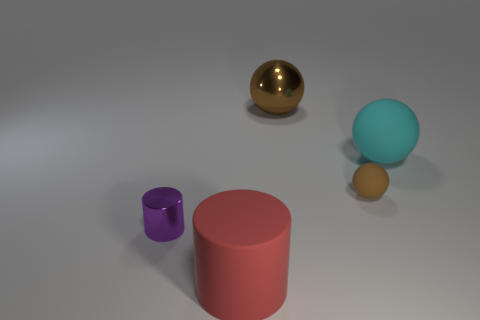What is the color of the big shiny thing?
Offer a terse response. Brown. Is the color of the cylinder behind the big red cylinder the same as the tiny sphere?
Your answer should be compact. No. What color is the shiny object in front of the brown sphere that is behind the matte object to the right of the small brown matte sphere?
Your response must be concise. Purple. Is the number of spheres in front of the tiny ball greater than the number of brown metallic objects behind the red rubber object?
Your answer should be compact. No. How many other things are there of the same size as the cyan ball?
Make the answer very short. 2. The object that is the same color as the small ball is what size?
Offer a very short reply. Large. What material is the big thing that is in front of the shiny thing that is on the left side of the large brown thing?
Make the answer very short. Rubber. Are there any big cylinders to the right of the large metal thing?
Give a very brief answer. No. Are there more small purple shiny cylinders behind the small brown sphere than large things?
Your response must be concise. No. Are there any large matte cylinders that have the same color as the big shiny sphere?
Offer a terse response. No. 